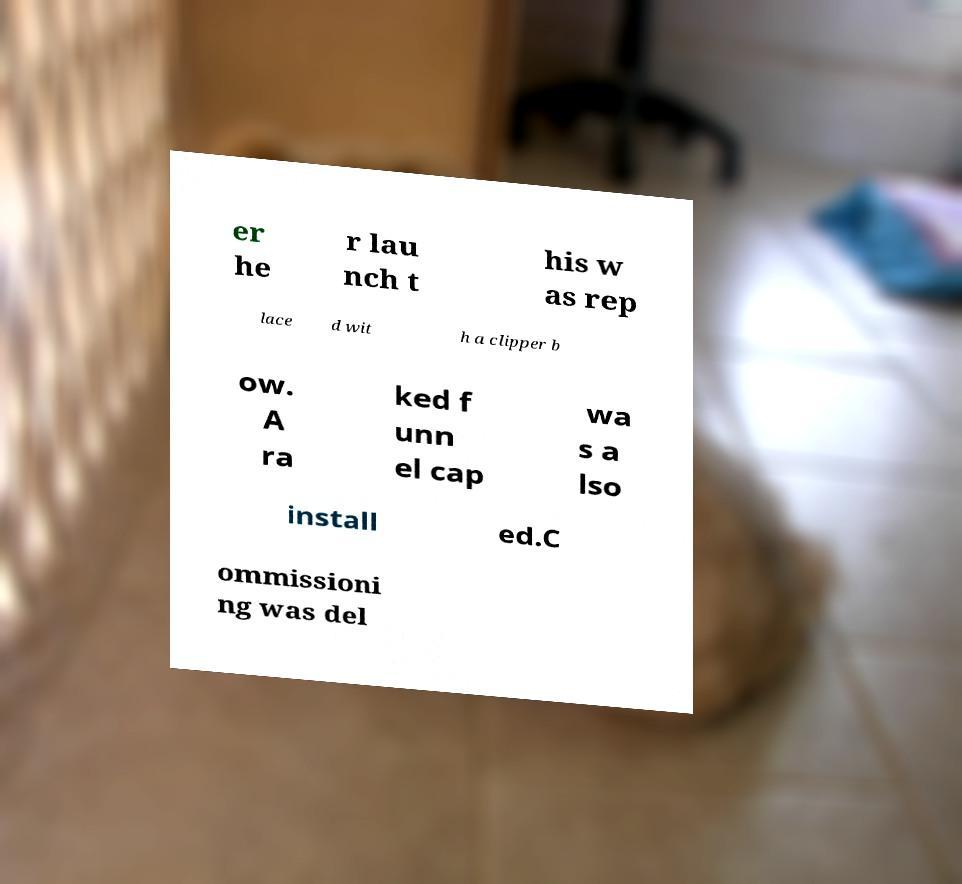For documentation purposes, I need the text within this image transcribed. Could you provide that? er he r lau nch t his w as rep lace d wit h a clipper b ow. A ra ked f unn el cap wa s a lso install ed.C ommissioni ng was del 